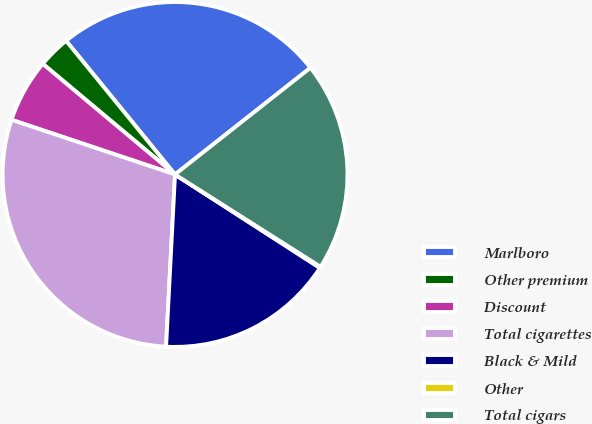<chart> <loc_0><loc_0><loc_500><loc_500><pie_chart><fcel>Marlboro<fcel>Other premium<fcel>Discount<fcel>Total cigarettes<fcel>Black & Mild<fcel>Other<fcel>Total cigars<nl><fcel>25.26%<fcel>3.03%<fcel>5.95%<fcel>29.31%<fcel>16.71%<fcel>0.12%<fcel>19.62%<nl></chart> 